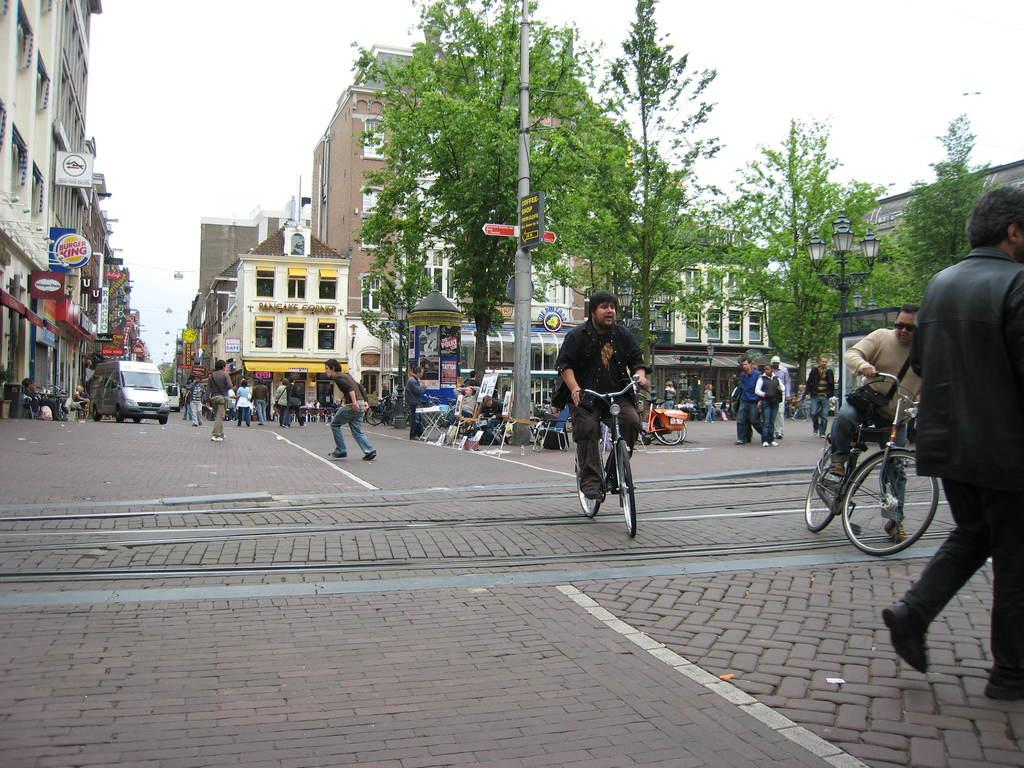What are the people in the image doing? The people in the image are riding bicycles. Where are the people riding their bicycles? The people are on a road. What can be seen in the background of the image? There are trees, buildings, a pole, and the sky visible in the background of the image. Can you tell me if the existence of a trail is depicted in the image? There is no trail visible in the image; it only shows people riding bicycles on a road. What type of parent is present in the image? There are no parents depicted in the image; it only shows people riding bicycles. 